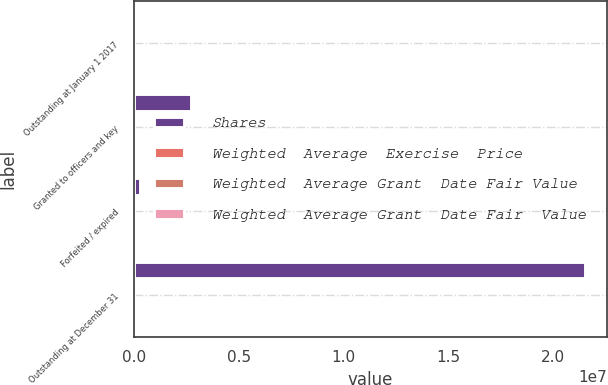Convert chart. <chart><loc_0><loc_0><loc_500><loc_500><stacked_bar_chart><ecel><fcel>Outstanding at January 1 2017<fcel>Granted to officers and key<fcel>Forfeited / expired<fcel>Outstanding at December 31<nl><fcel>Shares<fcel>86.78<fcel>2.70164e+06<fcel>269334<fcel>2.14999e+07<nl><fcel>Weighted  Average  Exercise  Price<fcel>82.13<fcel>95.66<fcel>94.23<fcel>86.86<nl><fcel>Weighted  Average Grant  Date Fair Value<fcel>78.5<fcel>90.11<fcel>79.43<fcel>80.04<nl><fcel>Weighted  Average Grant  Date Fair  Value<fcel>66.92<fcel>86.78<fcel>78.14<fcel>74.06<nl></chart> 